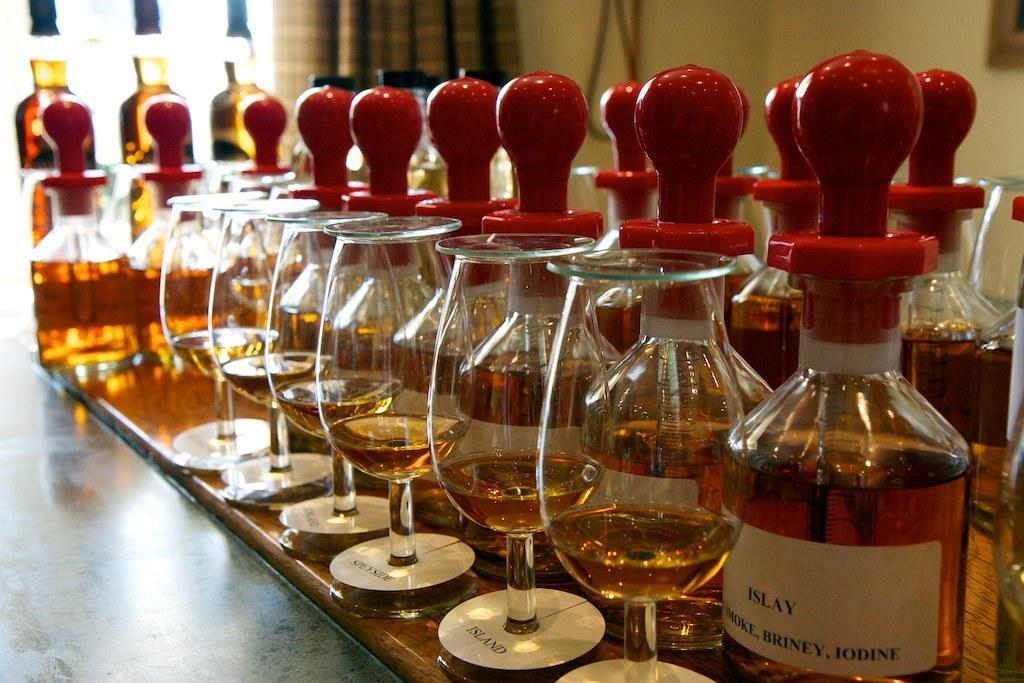What type of containers are visible in the image? There are glass bottles in the image. What else can be seen on the table in the image? There are glasses on a table in the image. What type of acoustics can be heard from the bridge in the image? There is no bridge present in the image, so it is not possible to determine the acoustics. 